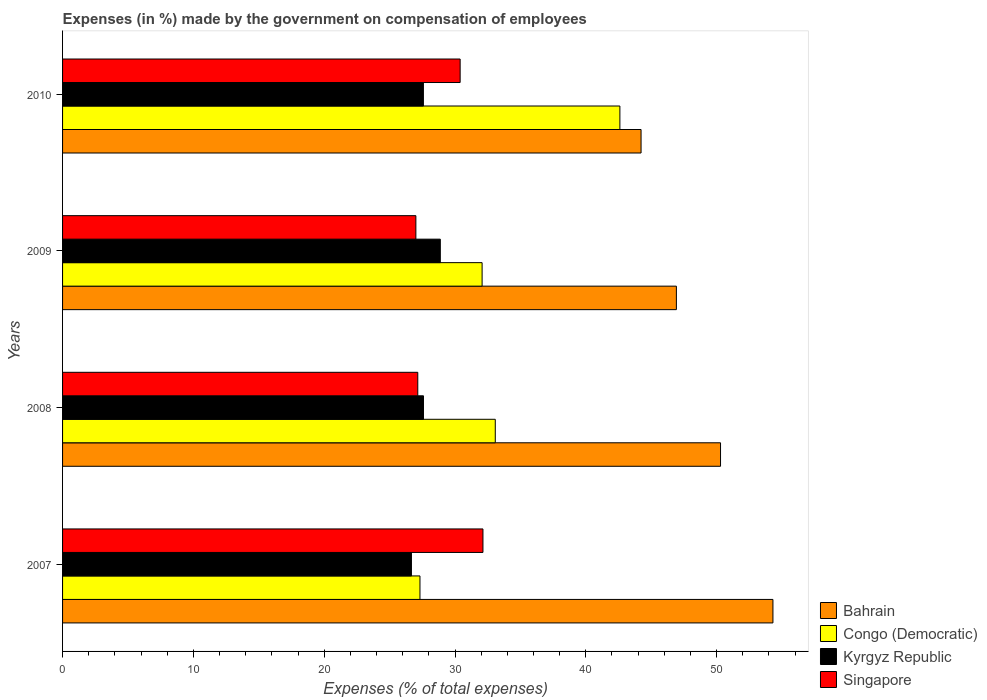How many groups of bars are there?
Keep it short and to the point. 4. Are the number of bars per tick equal to the number of legend labels?
Make the answer very short. Yes. Are the number of bars on each tick of the Y-axis equal?
Offer a terse response. Yes. How many bars are there on the 4th tick from the top?
Provide a short and direct response. 4. How many bars are there on the 3rd tick from the bottom?
Ensure brevity in your answer.  4. In how many cases, is the number of bars for a given year not equal to the number of legend labels?
Keep it short and to the point. 0. What is the percentage of expenses made by the government on compensation of employees in Congo (Democratic) in 2008?
Offer a terse response. 33.08. Across all years, what is the maximum percentage of expenses made by the government on compensation of employees in Congo (Democratic)?
Your answer should be very brief. 42.61. Across all years, what is the minimum percentage of expenses made by the government on compensation of employees in Kyrgyz Republic?
Make the answer very short. 26.67. In which year was the percentage of expenses made by the government on compensation of employees in Singapore maximum?
Offer a terse response. 2007. What is the total percentage of expenses made by the government on compensation of employees in Bahrain in the graph?
Make the answer very short. 195.75. What is the difference between the percentage of expenses made by the government on compensation of employees in Kyrgyz Republic in 2007 and that in 2009?
Your response must be concise. -2.21. What is the difference between the percentage of expenses made by the government on compensation of employees in Congo (Democratic) in 2010 and the percentage of expenses made by the government on compensation of employees in Singapore in 2008?
Your answer should be compact. 15.45. What is the average percentage of expenses made by the government on compensation of employees in Bahrain per year?
Your response must be concise. 48.94. In the year 2008, what is the difference between the percentage of expenses made by the government on compensation of employees in Bahrain and percentage of expenses made by the government on compensation of employees in Congo (Democratic)?
Provide a short and direct response. 17.22. What is the ratio of the percentage of expenses made by the government on compensation of employees in Singapore in 2008 to that in 2009?
Give a very brief answer. 1.01. Is the difference between the percentage of expenses made by the government on compensation of employees in Bahrain in 2007 and 2009 greater than the difference between the percentage of expenses made by the government on compensation of employees in Congo (Democratic) in 2007 and 2009?
Your answer should be compact. Yes. What is the difference between the highest and the second highest percentage of expenses made by the government on compensation of employees in Congo (Democratic)?
Provide a short and direct response. 9.53. What is the difference between the highest and the lowest percentage of expenses made by the government on compensation of employees in Congo (Democratic)?
Your answer should be compact. 15.28. Is it the case that in every year, the sum of the percentage of expenses made by the government on compensation of employees in Bahrain and percentage of expenses made by the government on compensation of employees in Kyrgyz Republic is greater than the sum of percentage of expenses made by the government on compensation of employees in Singapore and percentage of expenses made by the government on compensation of employees in Congo (Democratic)?
Give a very brief answer. Yes. What does the 2nd bar from the top in 2008 represents?
Ensure brevity in your answer.  Kyrgyz Republic. What does the 3rd bar from the bottom in 2007 represents?
Provide a succinct answer. Kyrgyz Republic. Does the graph contain grids?
Offer a very short reply. No. Where does the legend appear in the graph?
Offer a terse response. Bottom right. How many legend labels are there?
Your response must be concise. 4. What is the title of the graph?
Your answer should be compact. Expenses (in %) made by the government on compensation of employees. What is the label or title of the X-axis?
Your answer should be compact. Expenses (% of total expenses). What is the label or title of the Y-axis?
Provide a short and direct response. Years. What is the Expenses (% of total expenses) of Bahrain in 2007?
Offer a terse response. 54.31. What is the Expenses (% of total expenses) of Congo (Democratic) in 2007?
Your answer should be compact. 27.32. What is the Expenses (% of total expenses) of Kyrgyz Republic in 2007?
Make the answer very short. 26.67. What is the Expenses (% of total expenses) of Singapore in 2007?
Your answer should be very brief. 32.14. What is the Expenses (% of total expenses) of Bahrain in 2008?
Ensure brevity in your answer.  50.3. What is the Expenses (% of total expenses) of Congo (Democratic) in 2008?
Keep it short and to the point. 33.08. What is the Expenses (% of total expenses) in Kyrgyz Republic in 2008?
Keep it short and to the point. 27.59. What is the Expenses (% of total expenses) in Singapore in 2008?
Provide a short and direct response. 27.15. What is the Expenses (% of total expenses) in Bahrain in 2009?
Provide a succinct answer. 46.93. What is the Expenses (% of total expenses) of Congo (Democratic) in 2009?
Ensure brevity in your answer.  32.07. What is the Expenses (% of total expenses) of Kyrgyz Republic in 2009?
Give a very brief answer. 28.88. What is the Expenses (% of total expenses) of Singapore in 2009?
Keep it short and to the point. 27.01. What is the Expenses (% of total expenses) in Bahrain in 2010?
Give a very brief answer. 44.22. What is the Expenses (% of total expenses) in Congo (Democratic) in 2010?
Offer a very short reply. 42.61. What is the Expenses (% of total expenses) of Kyrgyz Republic in 2010?
Ensure brevity in your answer.  27.59. What is the Expenses (% of total expenses) in Singapore in 2010?
Keep it short and to the point. 30.39. Across all years, what is the maximum Expenses (% of total expenses) in Bahrain?
Ensure brevity in your answer.  54.31. Across all years, what is the maximum Expenses (% of total expenses) in Congo (Democratic)?
Make the answer very short. 42.61. Across all years, what is the maximum Expenses (% of total expenses) of Kyrgyz Republic?
Offer a very short reply. 28.88. Across all years, what is the maximum Expenses (% of total expenses) of Singapore?
Keep it short and to the point. 32.14. Across all years, what is the minimum Expenses (% of total expenses) in Bahrain?
Offer a terse response. 44.22. Across all years, what is the minimum Expenses (% of total expenses) of Congo (Democratic)?
Provide a short and direct response. 27.32. Across all years, what is the minimum Expenses (% of total expenses) of Kyrgyz Republic?
Your response must be concise. 26.67. Across all years, what is the minimum Expenses (% of total expenses) of Singapore?
Provide a succinct answer. 27.01. What is the total Expenses (% of total expenses) in Bahrain in the graph?
Make the answer very short. 195.75. What is the total Expenses (% of total expenses) of Congo (Democratic) in the graph?
Your answer should be very brief. 135.08. What is the total Expenses (% of total expenses) in Kyrgyz Republic in the graph?
Offer a very short reply. 110.72. What is the total Expenses (% of total expenses) in Singapore in the graph?
Provide a succinct answer. 116.69. What is the difference between the Expenses (% of total expenses) of Bahrain in 2007 and that in 2008?
Your response must be concise. 4.01. What is the difference between the Expenses (% of total expenses) in Congo (Democratic) in 2007 and that in 2008?
Make the answer very short. -5.76. What is the difference between the Expenses (% of total expenses) of Kyrgyz Republic in 2007 and that in 2008?
Keep it short and to the point. -0.92. What is the difference between the Expenses (% of total expenses) of Singapore in 2007 and that in 2008?
Give a very brief answer. 4.98. What is the difference between the Expenses (% of total expenses) of Bahrain in 2007 and that in 2009?
Your response must be concise. 7.38. What is the difference between the Expenses (% of total expenses) of Congo (Democratic) in 2007 and that in 2009?
Provide a short and direct response. -4.75. What is the difference between the Expenses (% of total expenses) of Kyrgyz Republic in 2007 and that in 2009?
Offer a terse response. -2.21. What is the difference between the Expenses (% of total expenses) of Singapore in 2007 and that in 2009?
Your answer should be compact. 5.13. What is the difference between the Expenses (% of total expenses) of Bahrain in 2007 and that in 2010?
Provide a short and direct response. 10.08. What is the difference between the Expenses (% of total expenses) of Congo (Democratic) in 2007 and that in 2010?
Keep it short and to the point. -15.28. What is the difference between the Expenses (% of total expenses) in Kyrgyz Republic in 2007 and that in 2010?
Provide a succinct answer. -0.92. What is the difference between the Expenses (% of total expenses) of Singapore in 2007 and that in 2010?
Your response must be concise. 1.74. What is the difference between the Expenses (% of total expenses) in Bahrain in 2008 and that in 2009?
Offer a terse response. 3.37. What is the difference between the Expenses (% of total expenses) in Congo (Democratic) in 2008 and that in 2009?
Give a very brief answer. 1.01. What is the difference between the Expenses (% of total expenses) of Kyrgyz Republic in 2008 and that in 2009?
Give a very brief answer. -1.29. What is the difference between the Expenses (% of total expenses) of Singapore in 2008 and that in 2009?
Keep it short and to the point. 0.15. What is the difference between the Expenses (% of total expenses) of Bahrain in 2008 and that in 2010?
Offer a terse response. 6.08. What is the difference between the Expenses (% of total expenses) of Congo (Democratic) in 2008 and that in 2010?
Make the answer very short. -9.53. What is the difference between the Expenses (% of total expenses) of Kyrgyz Republic in 2008 and that in 2010?
Your answer should be very brief. 0.01. What is the difference between the Expenses (% of total expenses) of Singapore in 2008 and that in 2010?
Keep it short and to the point. -3.24. What is the difference between the Expenses (% of total expenses) of Bahrain in 2009 and that in 2010?
Provide a short and direct response. 2.7. What is the difference between the Expenses (% of total expenses) of Congo (Democratic) in 2009 and that in 2010?
Keep it short and to the point. -10.53. What is the difference between the Expenses (% of total expenses) of Kyrgyz Republic in 2009 and that in 2010?
Provide a succinct answer. 1.29. What is the difference between the Expenses (% of total expenses) in Singapore in 2009 and that in 2010?
Offer a terse response. -3.38. What is the difference between the Expenses (% of total expenses) in Bahrain in 2007 and the Expenses (% of total expenses) in Congo (Democratic) in 2008?
Give a very brief answer. 21.23. What is the difference between the Expenses (% of total expenses) in Bahrain in 2007 and the Expenses (% of total expenses) in Kyrgyz Republic in 2008?
Your answer should be very brief. 26.72. What is the difference between the Expenses (% of total expenses) in Bahrain in 2007 and the Expenses (% of total expenses) in Singapore in 2008?
Your answer should be very brief. 27.15. What is the difference between the Expenses (% of total expenses) of Congo (Democratic) in 2007 and the Expenses (% of total expenses) of Kyrgyz Republic in 2008?
Provide a succinct answer. -0.27. What is the difference between the Expenses (% of total expenses) of Congo (Democratic) in 2007 and the Expenses (% of total expenses) of Singapore in 2008?
Keep it short and to the point. 0.17. What is the difference between the Expenses (% of total expenses) of Kyrgyz Republic in 2007 and the Expenses (% of total expenses) of Singapore in 2008?
Your response must be concise. -0.49. What is the difference between the Expenses (% of total expenses) in Bahrain in 2007 and the Expenses (% of total expenses) in Congo (Democratic) in 2009?
Your response must be concise. 22.23. What is the difference between the Expenses (% of total expenses) of Bahrain in 2007 and the Expenses (% of total expenses) of Kyrgyz Republic in 2009?
Your answer should be very brief. 25.43. What is the difference between the Expenses (% of total expenses) of Bahrain in 2007 and the Expenses (% of total expenses) of Singapore in 2009?
Your response must be concise. 27.3. What is the difference between the Expenses (% of total expenses) of Congo (Democratic) in 2007 and the Expenses (% of total expenses) of Kyrgyz Republic in 2009?
Your response must be concise. -1.55. What is the difference between the Expenses (% of total expenses) of Congo (Democratic) in 2007 and the Expenses (% of total expenses) of Singapore in 2009?
Ensure brevity in your answer.  0.31. What is the difference between the Expenses (% of total expenses) in Kyrgyz Republic in 2007 and the Expenses (% of total expenses) in Singapore in 2009?
Provide a short and direct response. -0.34. What is the difference between the Expenses (% of total expenses) in Bahrain in 2007 and the Expenses (% of total expenses) in Congo (Democratic) in 2010?
Make the answer very short. 11.7. What is the difference between the Expenses (% of total expenses) in Bahrain in 2007 and the Expenses (% of total expenses) in Kyrgyz Republic in 2010?
Your answer should be compact. 26.72. What is the difference between the Expenses (% of total expenses) in Bahrain in 2007 and the Expenses (% of total expenses) in Singapore in 2010?
Your response must be concise. 23.91. What is the difference between the Expenses (% of total expenses) of Congo (Democratic) in 2007 and the Expenses (% of total expenses) of Kyrgyz Republic in 2010?
Keep it short and to the point. -0.26. What is the difference between the Expenses (% of total expenses) of Congo (Democratic) in 2007 and the Expenses (% of total expenses) of Singapore in 2010?
Provide a short and direct response. -3.07. What is the difference between the Expenses (% of total expenses) of Kyrgyz Republic in 2007 and the Expenses (% of total expenses) of Singapore in 2010?
Your answer should be very brief. -3.72. What is the difference between the Expenses (% of total expenses) of Bahrain in 2008 and the Expenses (% of total expenses) of Congo (Democratic) in 2009?
Give a very brief answer. 18.23. What is the difference between the Expenses (% of total expenses) of Bahrain in 2008 and the Expenses (% of total expenses) of Kyrgyz Republic in 2009?
Provide a succinct answer. 21.42. What is the difference between the Expenses (% of total expenses) in Bahrain in 2008 and the Expenses (% of total expenses) in Singapore in 2009?
Your answer should be very brief. 23.29. What is the difference between the Expenses (% of total expenses) of Congo (Democratic) in 2008 and the Expenses (% of total expenses) of Kyrgyz Republic in 2009?
Keep it short and to the point. 4.2. What is the difference between the Expenses (% of total expenses) of Congo (Democratic) in 2008 and the Expenses (% of total expenses) of Singapore in 2009?
Provide a short and direct response. 6.07. What is the difference between the Expenses (% of total expenses) in Kyrgyz Republic in 2008 and the Expenses (% of total expenses) in Singapore in 2009?
Provide a succinct answer. 0.58. What is the difference between the Expenses (% of total expenses) of Bahrain in 2008 and the Expenses (% of total expenses) of Congo (Democratic) in 2010?
Make the answer very short. 7.69. What is the difference between the Expenses (% of total expenses) of Bahrain in 2008 and the Expenses (% of total expenses) of Kyrgyz Republic in 2010?
Offer a very short reply. 22.71. What is the difference between the Expenses (% of total expenses) in Bahrain in 2008 and the Expenses (% of total expenses) in Singapore in 2010?
Provide a short and direct response. 19.91. What is the difference between the Expenses (% of total expenses) of Congo (Democratic) in 2008 and the Expenses (% of total expenses) of Kyrgyz Republic in 2010?
Provide a short and direct response. 5.49. What is the difference between the Expenses (% of total expenses) of Congo (Democratic) in 2008 and the Expenses (% of total expenses) of Singapore in 2010?
Give a very brief answer. 2.69. What is the difference between the Expenses (% of total expenses) in Kyrgyz Republic in 2008 and the Expenses (% of total expenses) in Singapore in 2010?
Keep it short and to the point. -2.8. What is the difference between the Expenses (% of total expenses) in Bahrain in 2009 and the Expenses (% of total expenses) in Congo (Democratic) in 2010?
Provide a succinct answer. 4.32. What is the difference between the Expenses (% of total expenses) in Bahrain in 2009 and the Expenses (% of total expenses) in Kyrgyz Republic in 2010?
Offer a terse response. 19.34. What is the difference between the Expenses (% of total expenses) in Bahrain in 2009 and the Expenses (% of total expenses) in Singapore in 2010?
Offer a terse response. 16.53. What is the difference between the Expenses (% of total expenses) of Congo (Democratic) in 2009 and the Expenses (% of total expenses) of Kyrgyz Republic in 2010?
Keep it short and to the point. 4.49. What is the difference between the Expenses (% of total expenses) in Congo (Democratic) in 2009 and the Expenses (% of total expenses) in Singapore in 2010?
Keep it short and to the point. 1.68. What is the difference between the Expenses (% of total expenses) in Kyrgyz Republic in 2009 and the Expenses (% of total expenses) in Singapore in 2010?
Offer a terse response. -1.52. What is the average Expenses (% of total expenses) of Bahrain per year?
Your response must be concise. 48.94. What is the average Expenses (% of total expenses) of Congo (Democratic) per year?
Provide a short and direct response. 33.77. What is the average Expenses (% of total expenses) of Kyrgyz Republic per year?
Provide a short and direct response. 27.68. What is the average Expenses (% of total expenses) of Singapore per year?
Give a very brief answer. 29.17. In the year 2007, what is the difference between the Expenses (% of total expenses) in Bahrain and Expenses (% of total expenses) in Congo (Democratic)?
Offer a very short reply. 26.98. In the year 2007, what is the difference between the Expenses (% of total expenses) of Bahrain and Expenses (% of total expenses) of Kyrgyz Republic?
Your response must be concise. 27.64. In the year 2007, what is the difference between the Expenses (% of total expenses) in Bahrain and Expenses (% of total expenses) in Singapore?
Your answer should be compact. 22.17. In the year 2007, what is the difference between the Expenses (% of total expenses) of Congo (Democratic) and Expenses (% of total expenses) of Kyrgyz Republic?
Your answer should be very brief. 0.65. In the year 2007, what is the difference between the Expenses (% of total expenses) of Congo (Democratic) and Expenses (% of total expenses) of Singapore?
Provide a succinct answer. -4.81. In the year 2007, what is the difference between the Expenses (% of total expenses) in Kyrgyz Republic and Expenses (% of total expenses) in Singapore?
Your answer should be very brief. -5.47. In the year 2008, what is the difference between the Expenses (% of total expenses) in Bahrain and Expenses (% of total expenses) in Congo (Democratic)?
Provide a short and direct response. 17.22. In the year 2008, what is the difference between the Expenses (% of total expenses) in Bahrain and Expenses (% of total expenses) in Kyrgyz Republic?
Your answer should be compact. 22.71. In the year 2008, what is the difference between the Expenses (% of total expenses) of Bahrain and Expenses (% of total expenses) of Singapore?
Your response must be concise. 23.14. In the year 2008, what is the difference between the Expenses (% of total expenses) of Congo (Democratic) and Expenses (% of total expenses) of Kyrgyz Republic?
Keep it short and to the point. 5.49. In the year 2008, what is the difference between the Expenses (% of total expenses) in Congo (Democratic) and Expenses (% of total expenses) in Singapore?
Offer a terse response. 5.92. In the year 2008, what is the difference between the Expenses (% of total expenses) in Kyrgyz Republic and Expenses (% of total expenses) in Singapore?
Ensure brevity in your answer.  0.44. In the year 2009, what is the difference between the Expenses (% of total expenses) in Bahrain and Expenses (% of total expenses) in Congo (Democratic)?
Provide a succinct answer. 14.85. In the year 2009, what is the difference between the Expenses (% of total expenses) of Bahrain and Expenses (% of total expenses) of Kyrgyz Republic?
Give a very brief answer. 18.05. In the year 2009, what is the difference between the Expenses (% of total expenses) of Bahrain and Expenses (% of total expenses) of Singapore?
Offer a terse response. 19.92. In the year 2009, what is the difference between the Expenses (% of total expenses) in Congo (Democratic) and Expenses (% of total expenses) in Kyrgyz Republic?
Keep it short and to the point. 3.2. In the year 2009, what is the difference between the Expenses (% of total expenses) in Congo (Democratic) and Expenses (% of total expenses) in Singapore?
Make the answer very short. 5.06. In the year 2009, what is the difference between the Expenses (% of total expenses) in Kyrgyz Republic and Expenses (% of total expenses) in Singapore?
Provide a succinct answer. 1.87. In the year 2010, what is the difference between the Expenses (% of total expenses) of Bahrain and Expenses (% of total expenses) of Congo (Democratic)?
Give a very brief answer. 1.62. In the year 2010, what is the difference between the Expenses (% of total expenses) in Bahrain and Expenses (% of total expenses) in Kyrgyz Republic?
Your response must be concise. 16.64. In the year 2010, what is the difference between the Expenses (% of total expenses) in Bahrain and Expenses (% of total expenses) in Singapore?
Offer a terse response. 13.83. In the year 2010, what is the difference between the Expenses (% of total expenses) of Congo (Democratic) and Expenses (% of total expenses) of Kyrgyz Republic?
Provide a short and direct response. 15.02. In the year 2010, what is the difference between the Expenses (% of total expenses) in Congo (Democratic) and Expenses (% of total expenses) in Singapore?
Your answer should be compact. 12.21. In the year 2010, what is the difference between the Expenses (% of total expenses) of Kyrgyz Republic and Expenses (% of total expenses) of Singapore?
Make the answer very short. -2.81. What is the ratio of the Expenses (% of total expenses) of Bahrain in 2007 to that in 2008?
Keep it short and to the point. 1.08. What is the ratio of the Expenses (% of total expenses) of Congo (Democratic) in 2007 to that in 2008?
Your answer should be compact. 0.83. What is the ratio of the Expenses (% of total expenses) of Kyrgyz Republic in 2007 to that in 2008?
Provide a succinct answer. 0.97. What is the ratio of the Expenses (% of total expenses) of Singapore in 2007 to that in 2008?
Offer a very short reply. 1.18. What is the ratio of the Expenses (% of total expenses) of Bahrain in 2007 to that in 2009?
Offer a very short reply. 1.16. What is the ratio of the Expenses (% of total expenses) of Congo (Democratic) in 2007 to that in 2009?
Provide a succinct answer. 0.85. What is the ratio of the Expenses (% of total expenses) in Kyrgyz Republic in 2007 to that in 2009?
Offer a very short reply. 0.92. What is the ratio of the Expenses (% of total expenses) of Singapore in 2007 to that in 2009?
Make the answer very short. 1.19. What is the ratio of the Expenses (% of total expenses) of Bahrain in 2007 to that in 2010?
Provide a short and direct response. 1.23. What is the ratio of the Expenses (% of total expenses) in Congo (Democratic) in 2007 to that in 2010?
Give a very brief answer. 0.64. What is the ratio of the Expenses (% of total expenses) in Kyrgyz Republic in 2007 to that in 2010?
Your answer should be very brief. 0.97. What is the ratio of the Expenses (% of total expenses) in Singapore in 2007 to that in 2010?
Provide a succinct answer. 1.06. What is the ratio of the Expenses (% of total expenses) of Bahrain in 2008 to that in 2009?
Your answer should be compact. 1.07. What is the ratio of the Expenses (% of total expenses) in Congo (Democratic) in 2008 to that in 2009?
Provide a short and direct response. 1.03. What is the ratio of the Expenses (% of total expenses) in Kyrgyz Republic in 2008 to that in 2009?
Your answer should be very brief. 0.96. What is the ratio of the Expenses (% of total expenses) of Singapore in 2008 to that in 2009?
Keep it short and to the point. 1.01. What is the ratio of the Expenses (% of total expenses) of Bahrain in 2008 to that in 2010?
Your answer should be very brief. 1.14. What is the ratio of the Expenses (% of total expenses) in Congo (Democratic) in 2008 to that in 2010?
Your answer should be compact. 0.78. What is the ratio of the Expenses (% of total expenses) of Singapore in 2008 to that in 2010?
Your answer should be compact. 0.89. What is the ratio of the Expenses (% of total expenses) of Bahrain in 2009 to that in 2010?
Provide a short and direct response. 1.06. What is the ratio of the Expenses (% of total expenses) of Congo (Democratic) in 2009 to that in 2010?
Make the answer very short. 0.75. What is the ratio of the Expenses (% of total expenses) in Kyrgyz Republic in 2009 to that in 2010?
Offer a terse response. 1.05. What is the ratio of the Expenses (% of total expenses) in Singapore in 2009 to that in 2010?
Provide a short and direct response. 0.89. What is the difference between the highest and the second highest Expenses (% of total expenses) in Bahrain?
Give a very brief answer. 4.01. What is the difference between the highest and the second highest Expenses (% of total expenses) of Congo (Democratic)?
Provide a short and direct response. 9.53. What is the difference between the highest and the second highest Expenses (% of total expenses) in Kyrgyz Republic?
Your answer should be compact. 1.29. What is the difference between the highest and the second highest Expenses (% of total expenses) of Singapore?
Provide a succinct answer. 1.74. What is the difference between the highest and the lowest Expenses (% of total expenses) in Bahrain?
Provide a succinct answer. 10.08. What is the difference between the highest and the lowest Expenses (% of total expenses) in Congo (Democratic)?
Give a very brief answer. 15.28. What is the difference between the highest and the lowest Expenses (% of total expenses) of Kyrgyz Republic?
Offer a terse response. 2.21. What is the difference between the highest and the lowest Expenses (% of total expenses) of Singapore?
Your answer should be very brief. 5.13. 